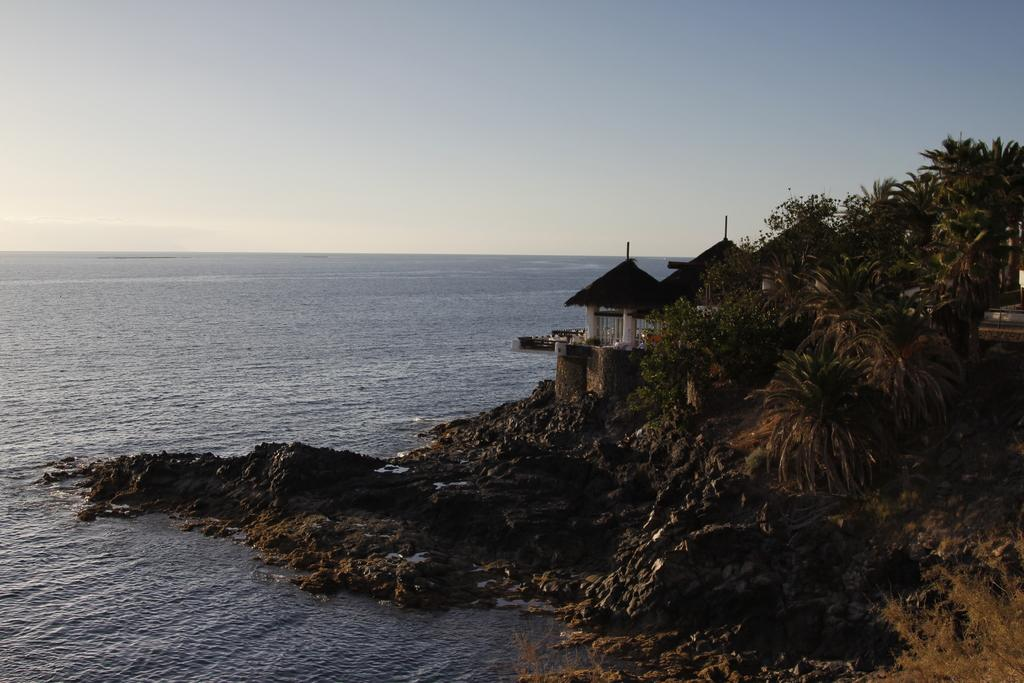What type of structure is present in the image? There is a house with a roof and pillars in the image. What can be seen on the hill in the image? There is a group of plants and trees on a hill in the image. What type of material is visible in the image? There are stones visible in the image. What is the main feature of the landscape in the image? There is a large water body in the image. How would you describe the weather in the image? The sky is visible in the image and appears cloudy. What type of treatment is being administered to the bun in the image? There is no bun present in the image, and therefore no treatment is being administered. 